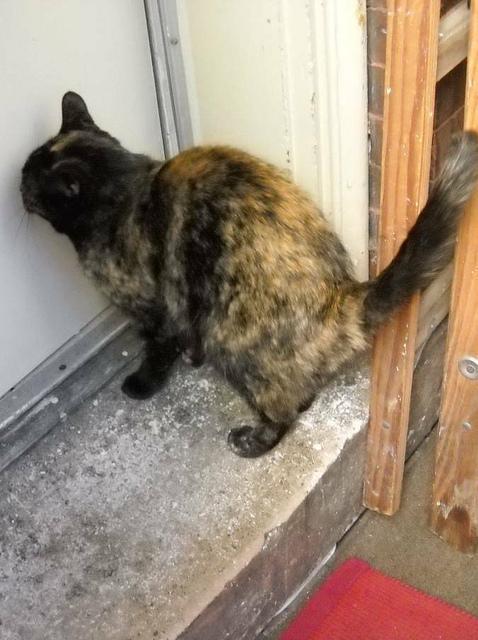How many red train carts can you see?
Give a very brief answer. 0. 